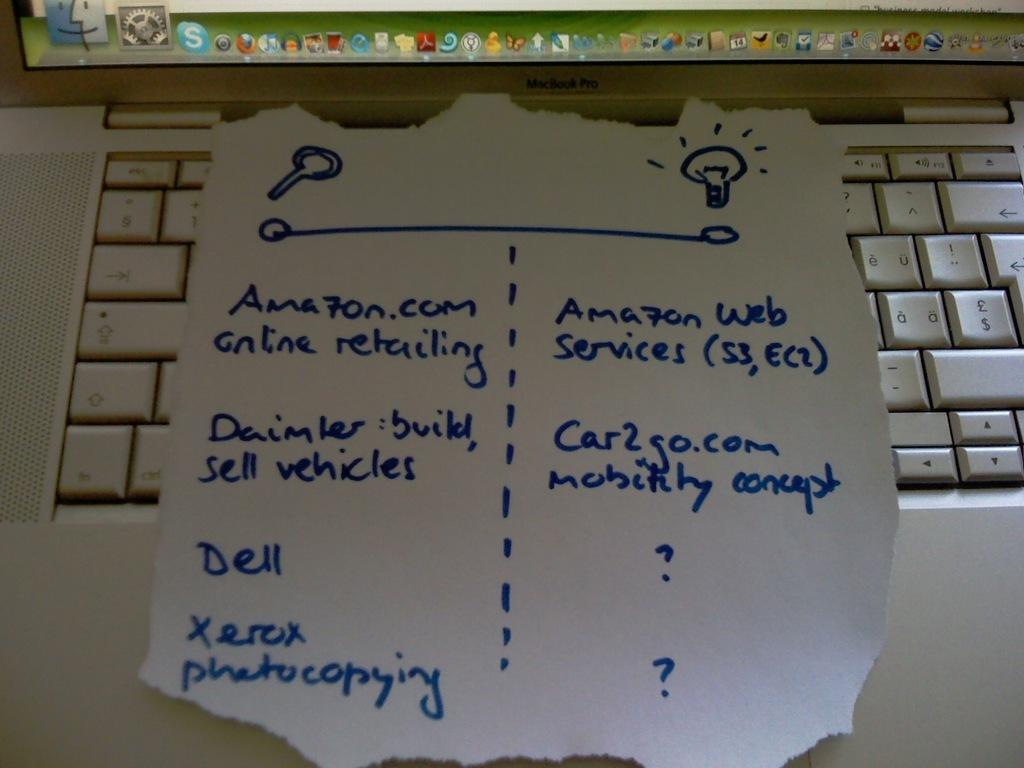<image>
Present a compact description of the photo's key features. A note about Amazon among other things on a laptop keyboard. 